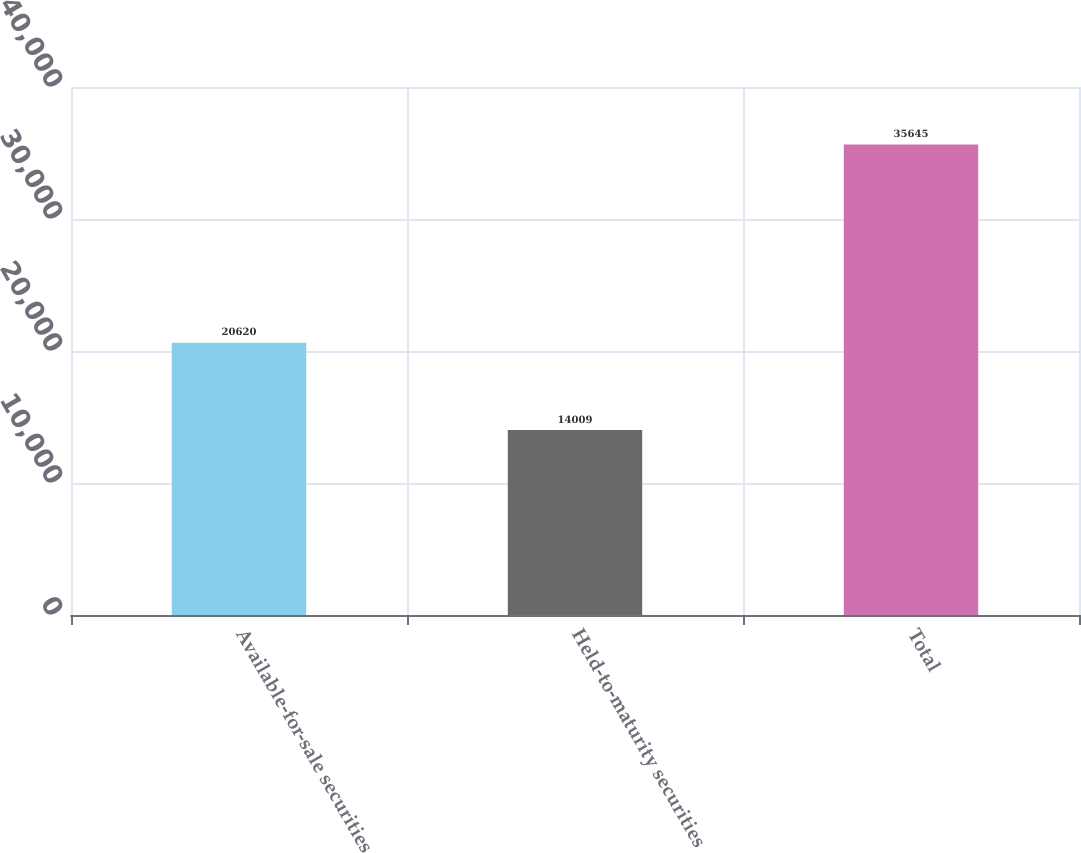<chart> <loc_0><loc_0><loc_500><loc_500><bar_chart><fcel>Available-for-sale securities<fcel>Held-to-maturity securities<fcel>Total<nl><fcel>20620<fcel>14009<fcel>35645<nl></chart> 